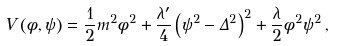Convert formula to latex. <formula><loc_0><loc_0><loc_500><loc_500>V \left ( \phi , \psi \right ) = \frac { 1 } { 2 } m ^ { 2 } \phi ^ { 2 } + \frac { \lambda ^ { \prime } } { 4 } \left ( \psi ^ { 2 } - \Delta ^ { 2 } \right ) ^ { 2 } + \frac { \lambda } { 2 } \phi ^ { 2 } \psi ^ { 2 } \, ,</formula> 